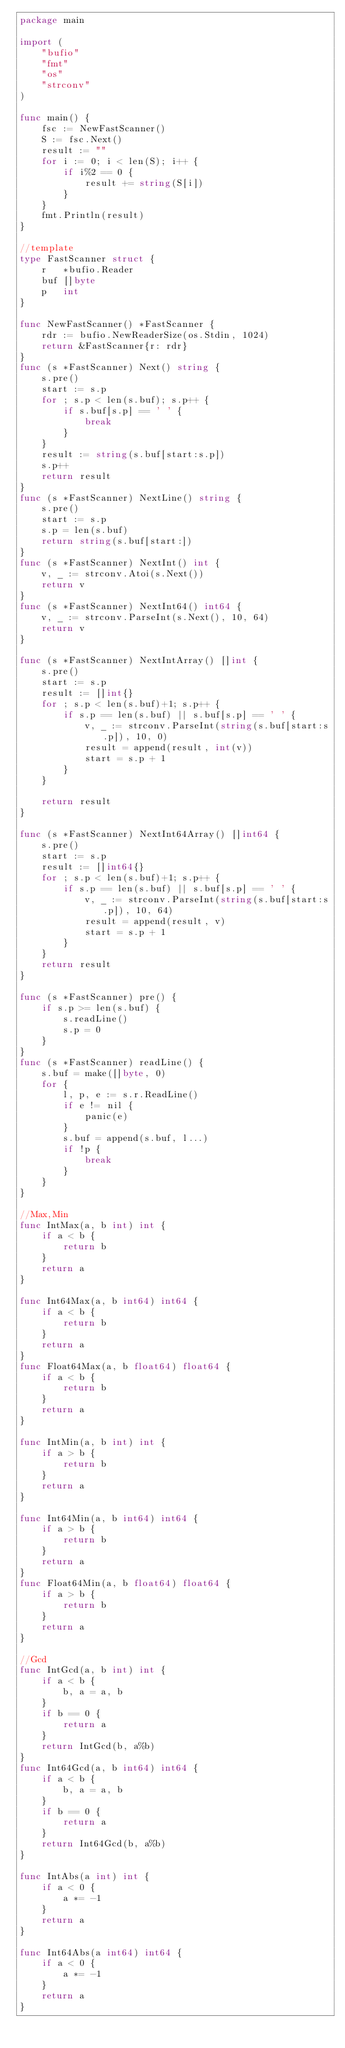<code> <loc_0><loc_0><loc_500><loc_500><_Go_>package main

import (
	"bufio"
	"fmt"
	"os"
	"strconv"
)

func main() {
	fsc := NewFastScanner()
	S := fsc.Next()
	result := ""
	for i := 0; i < len(S); i++ {
		if i%2 == 0 {
			result += string(S[i])
		}
	}
	fmt.Println(result)
}

//template
type FastScanner struct {
	r   *bufio.Reader
	buf []byte
	p   int
}

func NewFastScanner() *FastScanner {
	rdr := bufio.NewReaderSize(os.Stdin, 1024)
	return &FastScanner{r: rdr}
}
func (s *FastScanner) Next() string {
	s.pre()
	start := s.p
	for ; s.p < len(s.buf); s.p++ {
		if s.buf[s.p] == ' ' {
			break
		}
	}
	result := string(s.buf[start:s.p])
	s.p++
	return result
}
func (s *FastScanner) NextLine() string {
	s.pre()
	start := s.p
	s.p = len(s.buf)
	return string(s.buf[start:])
}
func (s *FastScanner) NextInt() int {
	v, _ := strconv.Atoi(s.Next())
	return v
}
func (s *FastScanner) NextInt64() int64 {
	v, _ := strconv.ParseInt(s.Next(), 10, 64)
	return v
}

func (s *FastScanner) NextIntArray() []int {
	s.pre()
	start := s.p
	result := []int{}
	for ; s.p < len(s.buf)+1; s.p++ {
		if s.p == len(s.buf) || s.buf[s.p] == ' ' {
			v, _ := strconv.ParseInt(string(s.buf[start:s.p]), 10, 0)
			result = append(result, int(v))
			start = s.p + 1
		}
	}

	return result
}

func (s *FastScanner) NextInt64Array() []int64 {
	s.pre()
	start := s.p
	result := []int64{}
	for ; s.p < len(s.buf)+1; s.p++ {
		if s.p == len(s.buf) || s.buf[s.p] == ' ' {
			v, _ := strconv.ParseInt(string(s.buf[start:s.p]), 10, 64)
			result = append(result, v)
			start = s.p + 1
		}
	}
	return result
}

func (s *FastScanner) pre() {
	if s.p >= len(s.buf) {
		s.readLine()
		s.p = 0
	}
}
func (s *FastScanner) readLine() {
	s.buf = make([]byte, 0)
	for {
		l, p, e := s.r.ReadLine()
		if e != nil {
			panic(e)
		}
		s.buf = append(s.buf, l...)
		if !p {
			break
		}
	}
}

//Max,Min
func IntMax(a, b int) int {
	if a < b {
		return b
	}
	return a
}

func Int64Max(a, b int64) int64 {
	if a < b {
		return b
	}
	return a
}
func Float64Max(a, b float64) float64 {
	if a < b {
		return b
	}
	return a
}

func IntMin(a, b int) int {
	if a > b {
		return b
	}
	return a
}

func Int64Min(a, b int64) int64 {
	if a > b {
		return b
	}
	return a
}
func Float64Min(a, b float64) float64 {
	if a > b {
		return b
	}
	return a
}

//Gcd
func IntGcd(a, b int) int {
	if a < b {
		b, a = a, b
	}
	if b == 0 {
		return a
	}
	return IntGcd(b, a%b)
}
func Int64Gcd(a, b int64) int64 {
	if a < b {
		b, a = a, b
	}
	if b == 0 {
		return a
	}
	return Int64Gcd(b, a%b)
}

func IntAbs(a int) int {
	if a < 0 {
		a *= -1
	}
	return a
}

func Int64Abs(a int64) int64 {
	if a < 0 {
		a *= -1
	}
	return a
}
</code> 